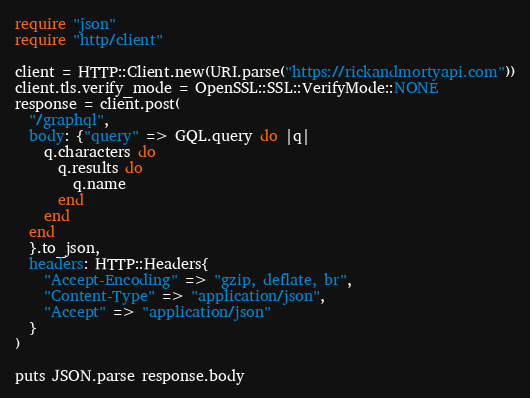<code> <loc_0><loc_0><loc_500><loc_500><_Crystal_>require "json"
require "http/client"

client = HTTP::Client.new(URI.parse("https://rickandmortyapi.com"))
client.tls.verify_mode = OpenSSL::SSL::VerifyMode::NONE
response = client.post(
  "/graphql",
  body: {"query" => GQL.query do |q|
    q.characters do
      q.results do
        q.name
      end
    end
  end
  }.to_json,
  headers: HTTP::Headers{
    "Accept-Encoding" => "gzip, deflate, br",
    "Content-Type" => "application/json",
    "Accept" => "application/json"
  }
)

puts JSON.parse response.body
</code> 